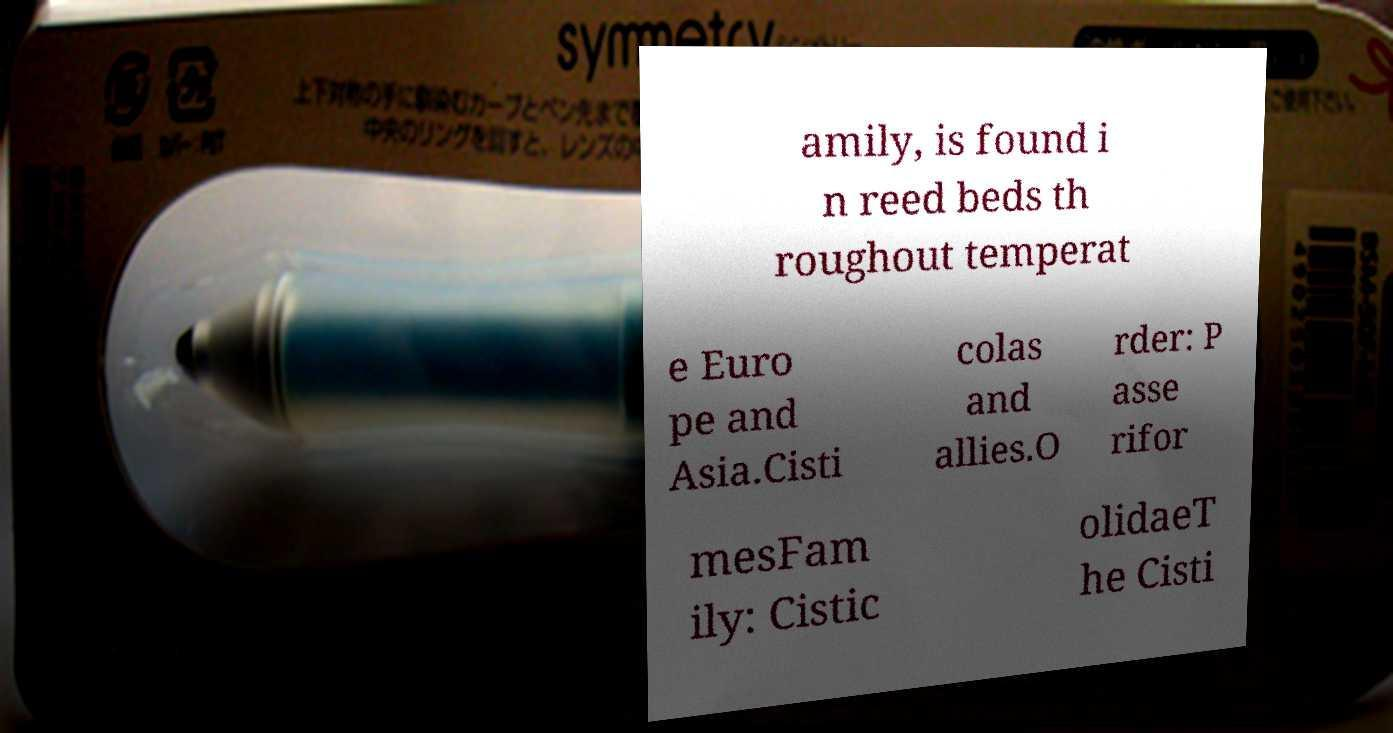Could you extract and type out the text from this image? amily, is found i n reed beds th roughout temperat e Euro pe and Asia.Cisti colas and allies.O rder: P asse rifor mesFam ily: Cistic olidaeT he Cisti 